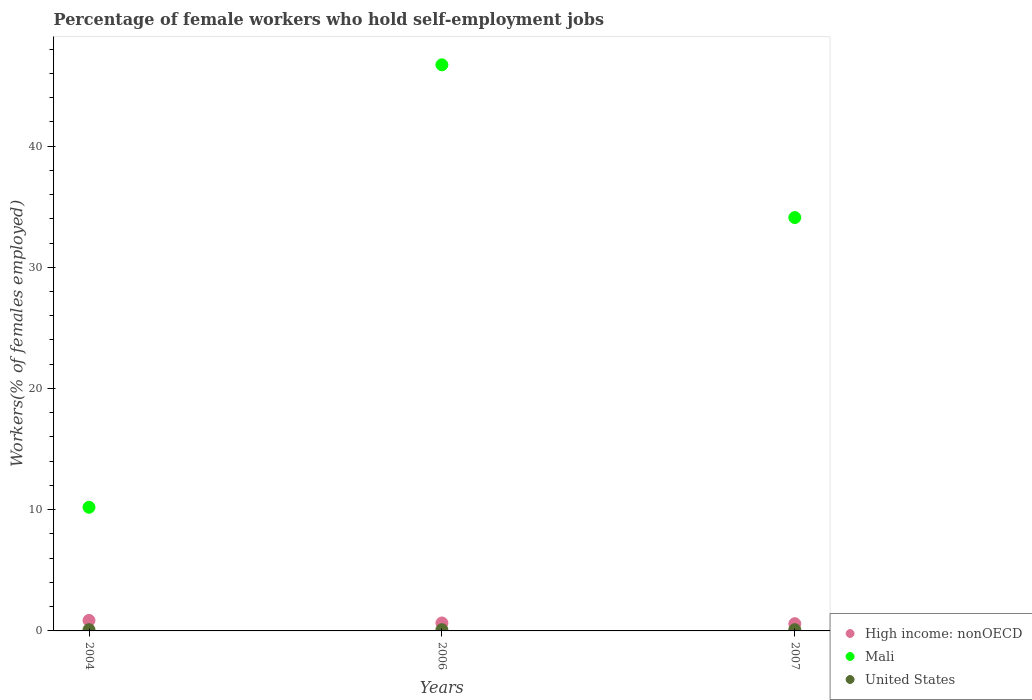How many different coloured dotlines are there?
Keep it short and to the point. 3. Is the number of dotlines equal to the number of legend labels?
Provide a short and direct response. Yes. What is the percentage of self-employed female workers in Mali in 2004?
Your answer should be compact. 10.2. Across all years, what is the maximum percentage of self-employed female workers in Mali?
Offer a terse response. 46.7. Across all years, what is the minimum percentage of self-employed female workers in Mali?
Offer a very short reply. 10.2. In which year was the percentage of self-employed female workers in High income: nonOECD maximum?
Offer a very short reply. 2004. In which year was the percentage of self-employed female workers in High income: nonOECD minimum?
Make the answer very short. 2007. What is the total percentage of self-employed female workers in United States in the graph?
Your answer should be compact. 0.3. What is the difference between the percentage of self-employed female workers in High income: nonOECD in 2004 and that in 2006?
Keep it short and to the point. 0.21. What is the difference between the percentage of self-employed female workers in United States in 2006 and the percentage of self-employed female workers in Mali in 2004?
Your answer should be very brief. -10.1. What is the average percentage of self-employed female workers in United States per year?
Your answer should be very brief. 0.1. In the year 2006, what is the difference between the percentage of self-employed female workers in High income: nonOECD and percentage of self-employed female workers in Mali?
Your response must be concise. -46.04. Is the difference between the percentage of self-employed female workers in High income: nonOECD in 2004 and 2007 greater than the difference between the percentage of self-employed female workers in Mali in 2004 and 2007?
Provide a succinct answer. Yes. What is the difference between the highest and the second highest percentage of self-employed female workers in United States?
Keep it short and to the point. 0. What is the difference between the highest and the lowest percentage of self-employed female workers in United States?
Ensure brevity in your answer.  0. Is it the case that in every year, the sum of the percentage of self-employed female workers in High income: nonOECD and percentage of self-employed female workers in Mali  is greater than the percentage of self-employed female workers in United States?
Your response must be concise. Yes. Does the percentage of self-employed female workers in High income: nonOECD monotonically increase over the years?
Your answer should be compact. No. Is the percentage of self-employed female workers in Mali strictly less than the percentage of self-employed female workers in United States over the years?
Keep it short and to the point. No. How many years are there in the graph?
Keep it short and to the point. 3. What is the difference between two consecutive major ticks on the Y-axis?
Offer a very short reply. 10. Where does the legend appear in the graph?
Offer a very short reply. Bottom right. How many legend labels are there?
Offer a terse response. 3. How are the legend labels stacked?
Your answer should be compact. Vertical. What is the title of the graph?
Offer a terse response. Percentage of female workers who hold self-employment jobs. Does "Qatar" appear as one of the legend labels in the graph?
Make the answer very short. No. What is the label or title of the X-axis?
Your response must be concise. Years. What is the label or title of the Y-axis?
Your answer should be very brief. Workers(% of females employed). What is the Workers(% of females employed) in High income: nonOECD in 2004?
Your answer should be compact. 0.87. What is the Workers(% of females employed) of Mali in 2004?
Make the answer very short. 10.2. What is the Workers(% of females employed) in United States in 2004?
Ensure brevity in your answer.  0.1. What is the Workers(% of females employed) in High income: nonOECD in 2006?
Provide a short and direct response. 0.66. What is the Workers(% of females employed) of Mali in 2006?
Ensure brevity in your answer.  46.7. What is the Workers(% of females employed) of United States in 2006?
Provide a short and direct response. 0.1. What is the Workers(% of females employed) of High income: nonOECD in 2007?
Keep it short and to the point. 0.6. What is the Workers(% of females employed) in Mali in 2007?
Provide a short and direct response. 34.1. What is the Workers(% of females employed) in United States in 2007?
Your answer should be very brief. 0.1. Across all years, what is the maximum Workers(% of females employed) in High income: nonOECD?
Provide a short and direct response. 0.87. Across all years, what is the maximum Workers(% of females employed) in Mali?
Provide a succinct answer. 46.7. Across all years, what is the maximum Workers(% of females employed) in United States?
Provide a succinct answer. 0.1. Across all years, what is the minimum Workers(% of females employed) of High income: nonOECD?
Provide a short and direct response. 0.6. Across all years, what is the minimum Workers(% of females employed) in Mali?
Your response must be concise. 10.2. Across all years, what is the minimum Workers(% of females employed) of United States?
Your answer should be compact. 0.1. What is the total Workers(% of females employed) in High income: nonOECD in the graph?
Your answer should be very brief. 2.12. What is the total Workers(% of females employed) in Mali in the graph?
Offer a terse response. 91. What is the difference between the Workers(% of females employed) of High income: nonOECD in 2004 and that in 2006?
Your response must be concise. 0.21. What is the difference between the Workers(% of females employed) in Mali in 2004 and that in 2006?
Give a very brief answer. -36.5. What is the difference between the Workers(% of females employed) of United States in 2004 and that in 2006?
Keep it short and to the point. 0. What is the difference between the Workers(% of females employed) of High income: nonOECD in 2004 and that in 2007?
Offer a very short reply. 0.27. What is the difference between the Workers(% of females employed) of Mali in 2004 and that in 2007?
Offer a terse response. -23.9. What is the difference between the Workers(% of females employed) in High income: nonOECD in 2006 and that in 2007?
Offer a very short reply. 0.06. What is the difference between the Workers(% of females employed) in High income: nonOECD in 2004 and the Workers(% of females employed) in Mali in 2006?
Give a very brief answer. -45.83. What is the difference between the Workers(% of females employed) in High income: nonOECD in 2004 and the Workers(% of females employed) in United States in 2006?
Provide a short and direct response. 0.77. What is the difference between the Workers(% of females employed) in Mali in 2004 and the Workers(% of females employed) in United States in 2006?
Make the answer very short. 10.1. What is the difference between the Workers(% of females employed) in High income: nonOECD in 2004 and the Workers(% of females employed) in Mali in 2007?
Keep it short and to the point. -33.23. What is the difference between the Workers(% of females employed) of High income: nonOECD in 2004 and the Workers(% of females employed) of United States in 2007?
Provide a short and direct response. 0.77. What is the difference between the Workers(% of females employed) of Mali in 2004 and the Workers(% of females employed) of United States in 2007?
Give a very brief answer. 10.1. What is the difference between the Workers(% of females employed) of High income: nonOECD in 2006 and the Workers(% of females employed) of Mali in 2007?
Your answer should be very brief. -33.44. What is the difference between the Workers(% of females employed) of High income: nonOECD in 2006 and the Workers(% of females employed) of United States in 2007?
Keep it short and to the point. 0.56. What is the difference between the Workers(% of females employed) of Mali in 2006 and the Workers(% of females employed) of United States in 2007?
Your response must be concise. 46.6. What is the average Workers(% of females employed) of High income: nonOECD per year?
Give a very brief answer. 0.71. What is the average Workers(% of females employed) of Mali per year?
Give a very brief answer. 30.33. What is the average Workers(% of females employed) in United States per year?
Make the answer very short. 0.1. In the year 2004, what is the difference between the Workers(% of females employed) of High income: nonOECD and Workers(% of females employed) of Mali?
Offer a very short reply. -9.33. In the year 2004, what is the difference between the Workers(% of females employed) of High income: nonOECD and Workers(% of females employed) of United States?
Make the answer very short. 0.77. In the year 2004, what is the difference between the Workers(% of females employed) in Mali and Workers(% of females employed) in United States?
Your response must be concise. 10.1. In the year 2006, what is the difference between the Workers(% of females employed) in High income: nonOECD and Workers(% of females employed) in Mali?
Offer a terse response. -46.04. In the year 2006, what is the difference between the Workers(% of females employed) in High income: nonOECD and Workers(% of females employed) in United States?
Provide a succinct answer. 0.56. In the year 2006, what is the difference between the Workers(% of females employed) in Mali and Workers(% of females employed) in United States?
Your response must be concise. 46.6. In the year 2007, what is the difference between the Workers(% of females employed) in High income: nonOECD and Workers(% of females employed) in Mali?
Keep it short and to the point. -33.5. In the year 2007, what is the difference between the Workers(% of females employed) in High income: nonOECD and Workers(% of females employed) in United States?
Offer a very short reply. 0.5. What is the ratio of the Workers(% of females employed) of High income: nonOECD in 2004 to that in 2006?
Make the answer very short. 1.32. What is the ratio of the Workers(% of females employed) in Mali in 2004 to that in 2006?
Provide a short and direct response. 0.22. What is the ratio of the Workers(% of females employed) of United States in 2004 to that in 2006?
Offer a very short reply. 1. What is the ratio of the Workers(% of females employed) in High income: nonOECD in 2004 to that in 2007?
Your response must be concise. 1.45. What is the ratio of the Workers(% of females employed) of Mali in 2004 to that in 2007?
Your response must be concise. 0.3. What is the ratio of the Workers(% of females employed) of United States in 2004 to that in 2007?
Make the answer very short. 1. What is the ratio of the Workers(% of females employed) of High income: nonOECD in 2006 to that in 2007?
Offer a very short reply. 1.1. What is the ratio of the Workers(% of females employed) in Mali in 2006 to that in 2007?
Ensure brevity in your answer.  1.37. What is the ratio of the Workers(% of females employed) of United States in 2006 to that in 2007?
Your answer should be compact. 1. What is the difference between the highest and the second highest Workers(% of females employed) in High income: nonOECD?
Give a very brief answer. 0.21. What is the difference between the highest and the second highest Workers(% of females employed) in Mali?
Offer a terse response. 12.6. What is the difference between the highest and the lowest Workers(% of females employed) of High income: nonOECD?
Offer a terse response. 0.27. What is the difference between the highest and the lowest Workers(% of females employed) in Mali?
Your response must be concise. 36.5. What is the difference between the highest and the lowest Workers(% of females employed) in United States?
Provide a succinct answer. 0. 